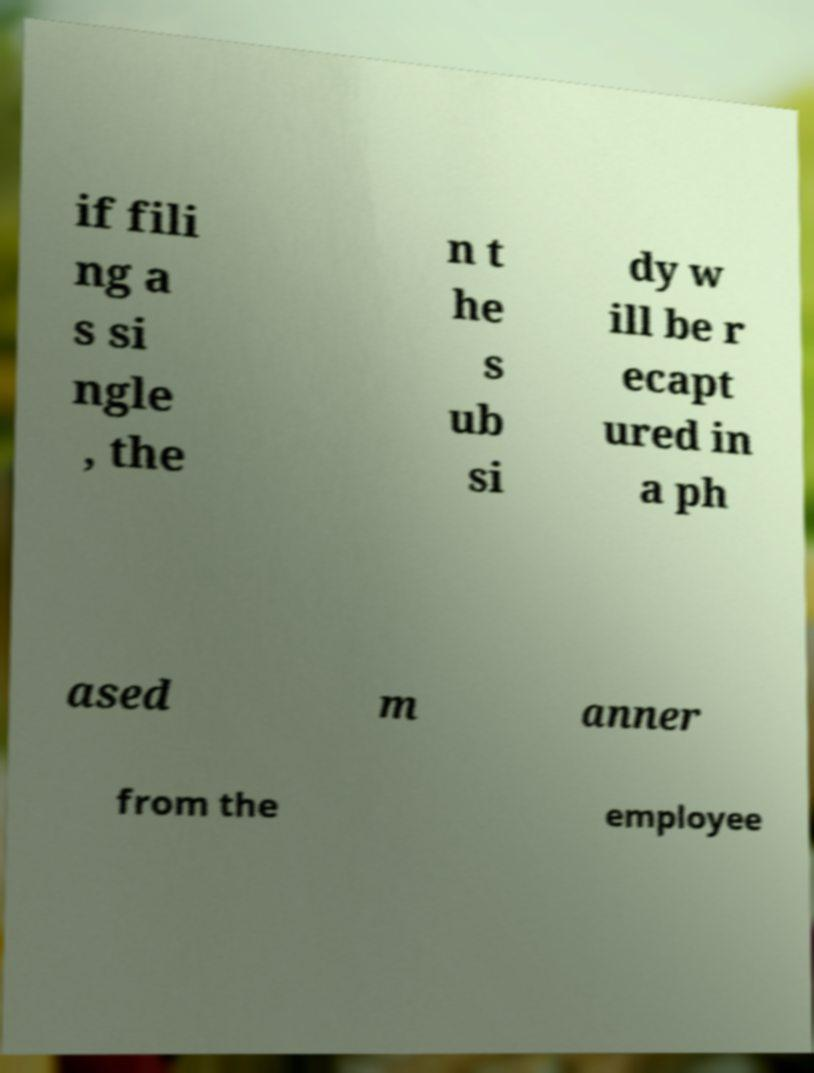Can you accurately transcribe the text from the provided image for me? if fili ng a s si ngle , the n t he s ub si dy w ill be r ecapt ured in a ph ased m anner from the employee 